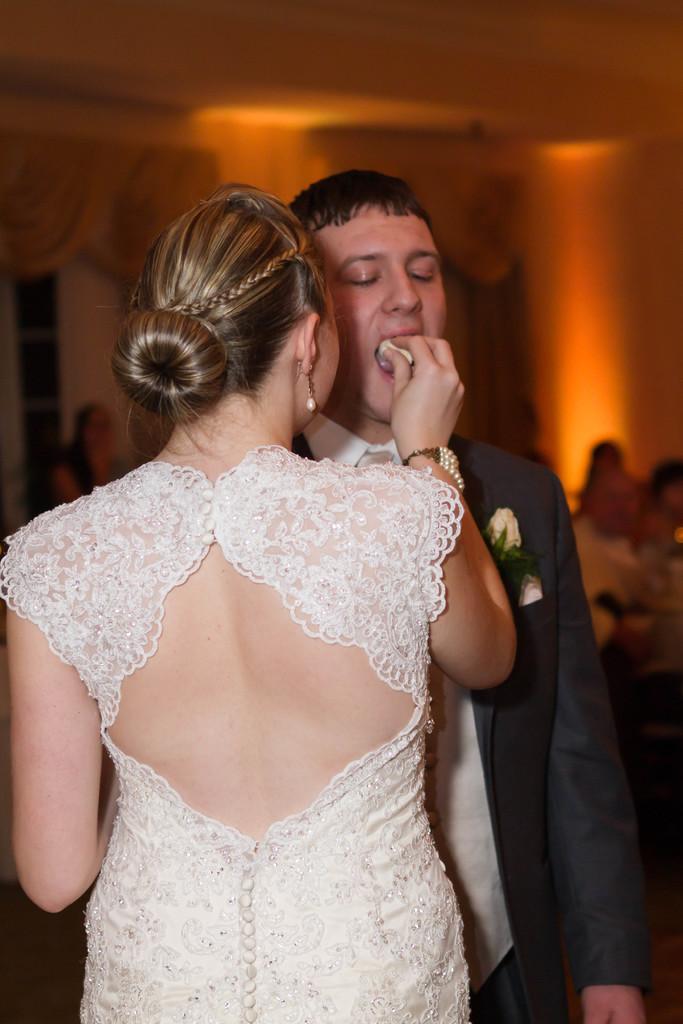Please provide a concise description of this image. In this image, we can see a woman is holding a food. She is feeding to a man. Background we can see blur view. Here there are few people, wall and curtains. 